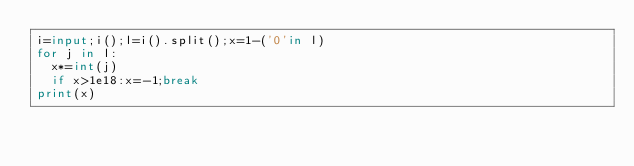<code> <loc_0><loc_0><loc_500><loc_500><_Python_>i=input;i();l=i().split();x=1-('0'in l)
for j in l:
  x*=int(j)
  if x>1e18:x=-1;break
print(x)
</code> 